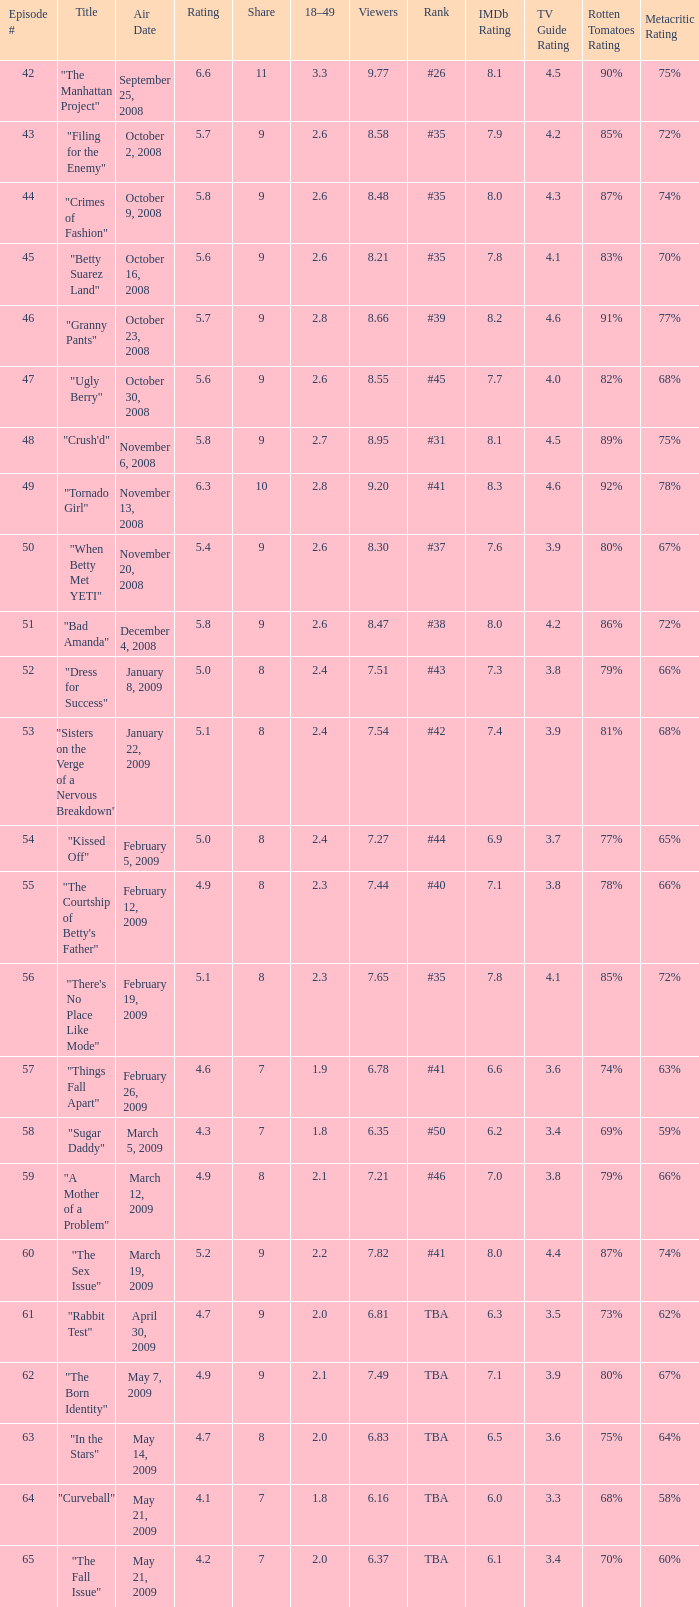What is the Air Date that has a 18–49 larger than 1.9, less than 7.54 viewers and a rating less than 4.9? April 30, 2009, May 14, 2009, May 21, 2009. 